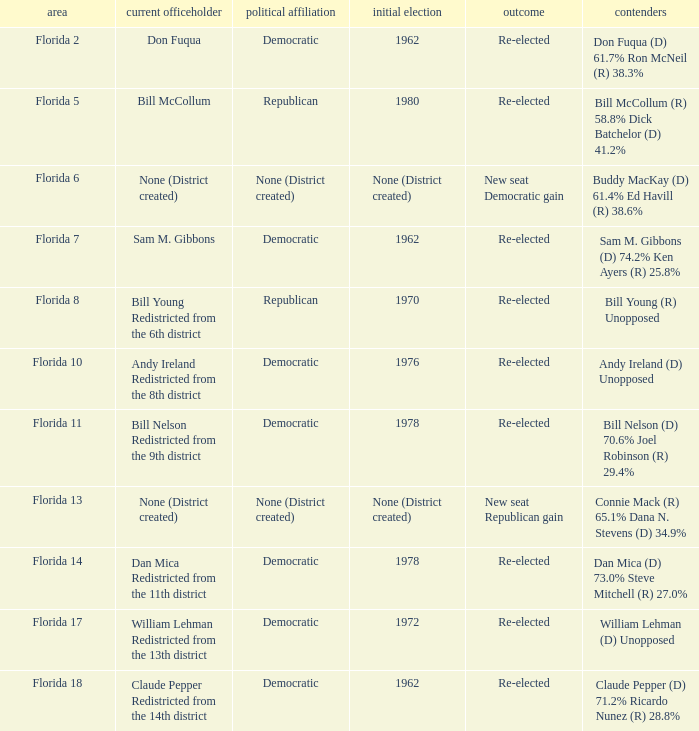 how many result with district being florida 14 1.0. 